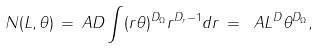Convert formula to latex. <formula><loc_0><loc_0><loc_500><loc_500>N ( L , \theta ) \, = \, A D \int ( r \theta ) ^ { D _ { \Omega } } r ^ { D _ { r } - 1 } d r \, = \ A L ^ { D } \theta ^ { D _ { \Omega } } ,</formula> 